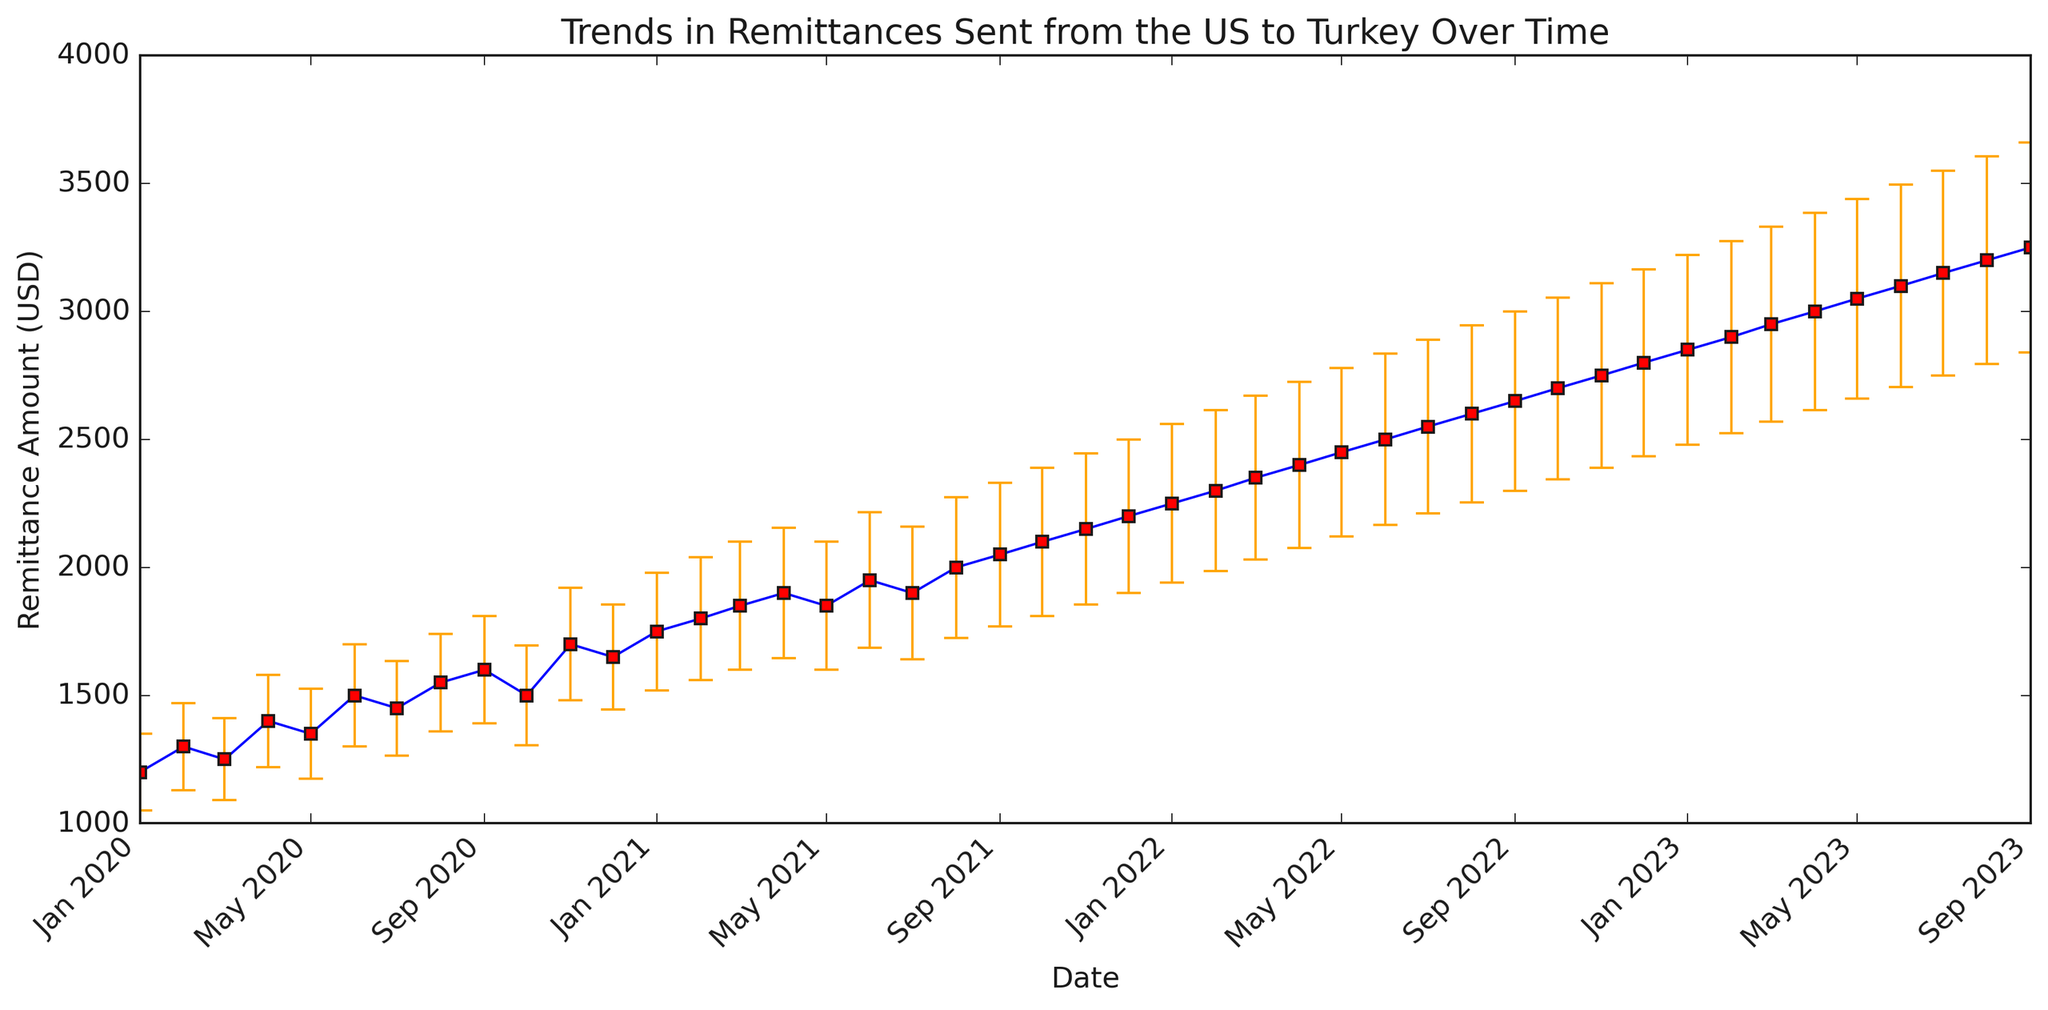What are the highest and lowest remittance amounts over the entire time period? By examining the plot, we can see the highest and lowest points on the y-axis. The highest amount is in "2023-09" with 3250 USD and the lowest amount is in "2020-01" with 1200 USD.
Answer: Highest: 3250 USD, Lowest: 1200 USD How do the remittance amounts in mid-2021 (July) compare to those in mid-2023 (July)? The plot shows that in "2021-07," the amount was 1900 USD, and in "2023-07," the amount was 3150 USD. Comparing these two values shows an increase.
Answer: 2021-07: 1900 USD, 2023-07: 3150 USD What is the average remittance amount from 2020 to the end of 2020? Looking at the plot, the monthly remittance values for 2020 (from January to December) are: 1200, 1300, 1250, 1400, 1350, 1500, 1450, 1550, 1600, 1500, 1700, 1650. Summing these values gives 17450 USD, and dividing them by 12 (the number of months) gives the average.
Answer: 1454.17 USD During which month and year did we observe the highest standard deviation in remittance? By examining the error bars on the plot, we can see the lengthiest error bar, which corresponds to the highest standard deviation. This occurs in "2023-09," with a standard deviation of 410 USD.
Answer: 2023-09 What is the general trend observed in remittance amounts from 2020 to 2023? Observing the overall progression of the data points in the plot from left to right, we see a general upward trend in the remittance amounts over time. This indicates an increase in remittances from the US to Turkey.
Answer: Increasing trend What month in 2021 had the smallest increase in remittance compared to the previous month? Checking the months sequentially for the smallest difference between consecutive months in 2021, we find that the difference between "2021-04" and "2021-05" is zero (both have 1850 USD).
Answer: May 2021 Between which consecutive months did the largest increase in remittance occur? By scanning the graph, noticing changes between each pair of months, the largest difference is between "2020-11" (1700 USD) and "2020-12" (1650 USD), which is an increase of 550 USD.
Answer: Nov 2020 - Dec 2020 How does the range of remittance amounts in 2023 compare to those in 2020? The range is calculated as the difference between the maximum and minimum values in each year. For 2020, the values range from 1200 to 1700 USD (range = 500 USD). For 2023, the values range from 2850 to 3250 USD (range = 400 USD).
Answer: 2020: 500 USD, 2023: 400 USD Which month showed the highest immediate drop in remittances? By observing the graph for sharp declines, the largest drop occurs between "2020-10" (1500 USD) and "2020-11" (1700 USD), showing the largest immediate decrease.
Answer: Oct 2020 - Nov 2020 What is the mean remittance for the year 2022? For 2022, the monthly remittance values are: 2250, 2300, 2350, 2400, 2450, 2500, 2550, 2600, 2650, 2700, 2750, 2800. Summing these values gives 30300 USD, and dividing by 12 gives the average.
Answer: 2525 USD 